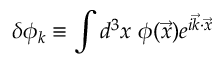Convert formula to latex. <formula><loc_0><loc_0><loc_500><loc_500>\delta \phi _ { k } \equiv \int d ^ { 3 } x \ \phi ( \vec { x } ) e ^ { i \vec { k } \cdot \vec { x } }</formula> 